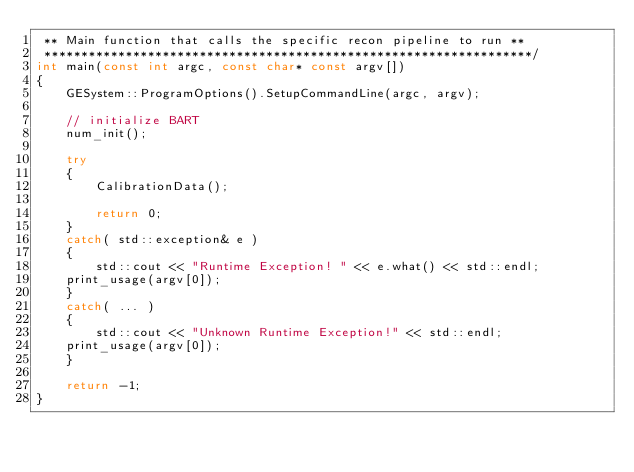<code> <loc_0><loc_0><loc_500><loc_500><_C++_> ** Main function that calls the specific recon pipeline to run **
 ******************************************************************/
int main(const int argc, const char* const argv[])
{
    GESystem::ProgramOptions().SetupCommandLine(argc, argv);

    // initialize BART
    num_init();

    try
    {
        CalibrationData();

        return 0;
    }
    catch( std::exception& e )
    {
        std::cout << "Runtime Exception! " << e.what() << std::endl;
	print_usage(argv[0]);
    }
    catch( ... )
    {
        std::cout << "Unknown Runtime Exception!" << std::endl;
	print_usage(argv[0]);
    }

    return -1;
}
</code> 